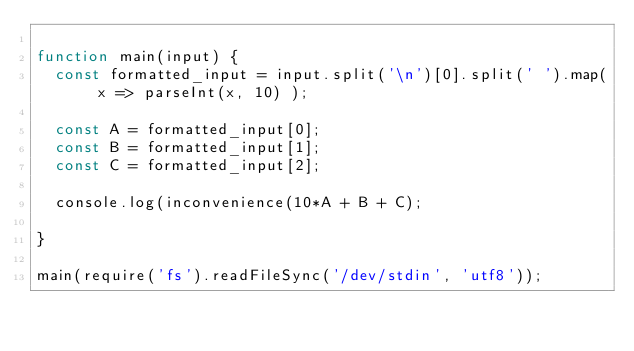Convert code to text. <code><loc_0><loc_0><loc_500><loc_500><_JavaScript_>
function main(input) {
  const formatted_input = input.split('\n')[0].split(' ').map( x => parseInt(x, 10) );

  const A = formatted_input[0];
  const B = formatted_input[1];
  const C = formatted_input[2];

  console.log(inconvenience(10*A + B + C);

}

main(require('fs').readFileSync('/dev/stdin', 'utf8'));
</code> 